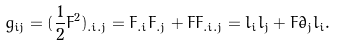Convert formula to latex. <formula><loc_0><loc_0><loc_500><loc_500>{ g _ { i j } } = { ( \frac { 1 } { 2 } { F ^ { 2 } } ) _ { { . i } { . j } } } = { F _ { . i } } { F _ { . j } } + F { F _ { { . i } { . j } } } = { l _ { i } } { l _ { j } } + F { { \dot { \partial } } _ { j } } { l _ { i } } .</formula> 